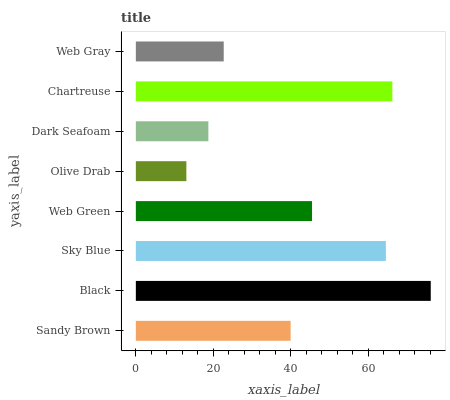Is Olive Drab the minimum?
Answer yes or no. Yes. Is Black the maximum?
Answer yes or no. Yes. Is Sky Blue the minimum?
Answer yes or no. No. Is Sky Blue the maximum?
Answer yes or no. No. Is Black greater than Sky Blue?
Answer yes or no. Yes. Is Sky Blue less than Black?
Answer yes or no. Yes. Is Sky Blue greater than Black?
Answer yes or no. No. Is Black less than Sky Blue?
Answer yes or no. No. Is Web Green the high median?
Answer yes or no. Yes. Is Sandy Brown the low median?
Answer yes or no. Yes. Is Dark Seafoam the high median?
Answer yes or no. No. Is Black the low median?
Answer yes or no. No. 